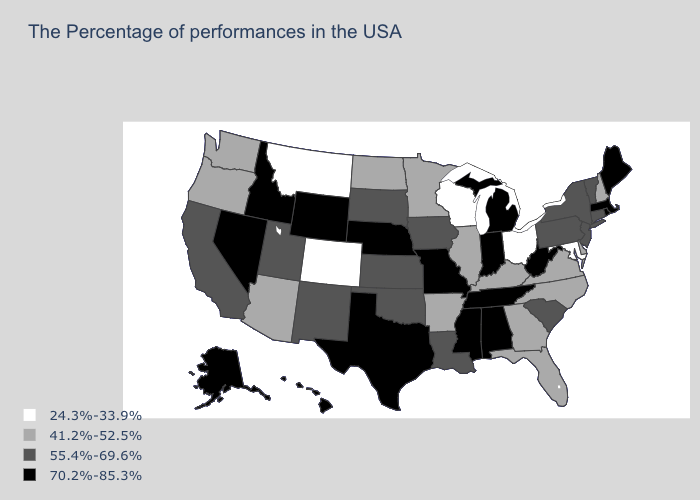Name the states that have a value in the range 55.4%-69.6%?
Keep it brief. Vermont, Connecticut, New York, New Jersey, Pennsylvania, South Carolina, Louisiana, Iowa, Kansas, Oklahoma, South Dakota, New Mexico, Utah, California. What is the value of North Dakota?
Be succinct. 41.2%-52.5%. What is the value of Michigan?
Short answer required. 70.2%-85.3%. What is the value of Maine?
Quick response, please. 70.2%-85.3%. Name the states that have a value in the range 55.4%-69.6%?
Concise answer only. Vermont, Connecticut, New York, New Jersey, Pennsylvania, South Carolina, Louisiana, Iowa, Kansas, Oklahoma, South Dakota, New Mexico, Utah, California. What is the highest value in states that border New Mexico?
Concise answer only. 70.2%-85.3%. What is the value of New Mexico?
Give a very brief answer. 55.4%-69.6%. What is the highest value in the USA?
Answer briefly. 70.2%-85.3%. Does West Virginia have a lower value than New Jersey?
Write a very short answer. No. Does Maryland have the lowest value in the USA?
Give a very brief answer. Yes. Name the states that have a value in the range 70.2%-85.3%?
Be succinct. Maine, Massachusetts, Rhode Island, West Virginia, Michigan, Indiana, Alabama, Tennessee, Mississippi, Missouri, Nebraska, Texas, Wyoming, Idaho, Nevada, Alaska, Hawaii. What is the value of Missouri?
Keep it brief. 70.2%-85.3%. Name the states that have a value in the range 41.2%-52.5%?
Short answer required. New Hampshire, Delaware, Virginia, North Carolina, Florida, Georgia, Kentucky, Illinois, Arkansas, Minnesota, North Dakota, Arizona, Washington, Oregon. Name the states that have a value in the range 24.3%-33.9%?
Write a very short answer. Maryland, Ohio, Wisconsin, Colorado, Montana. Does Arkansas have a lower value than Georgia?
Write a very short answer. No. 